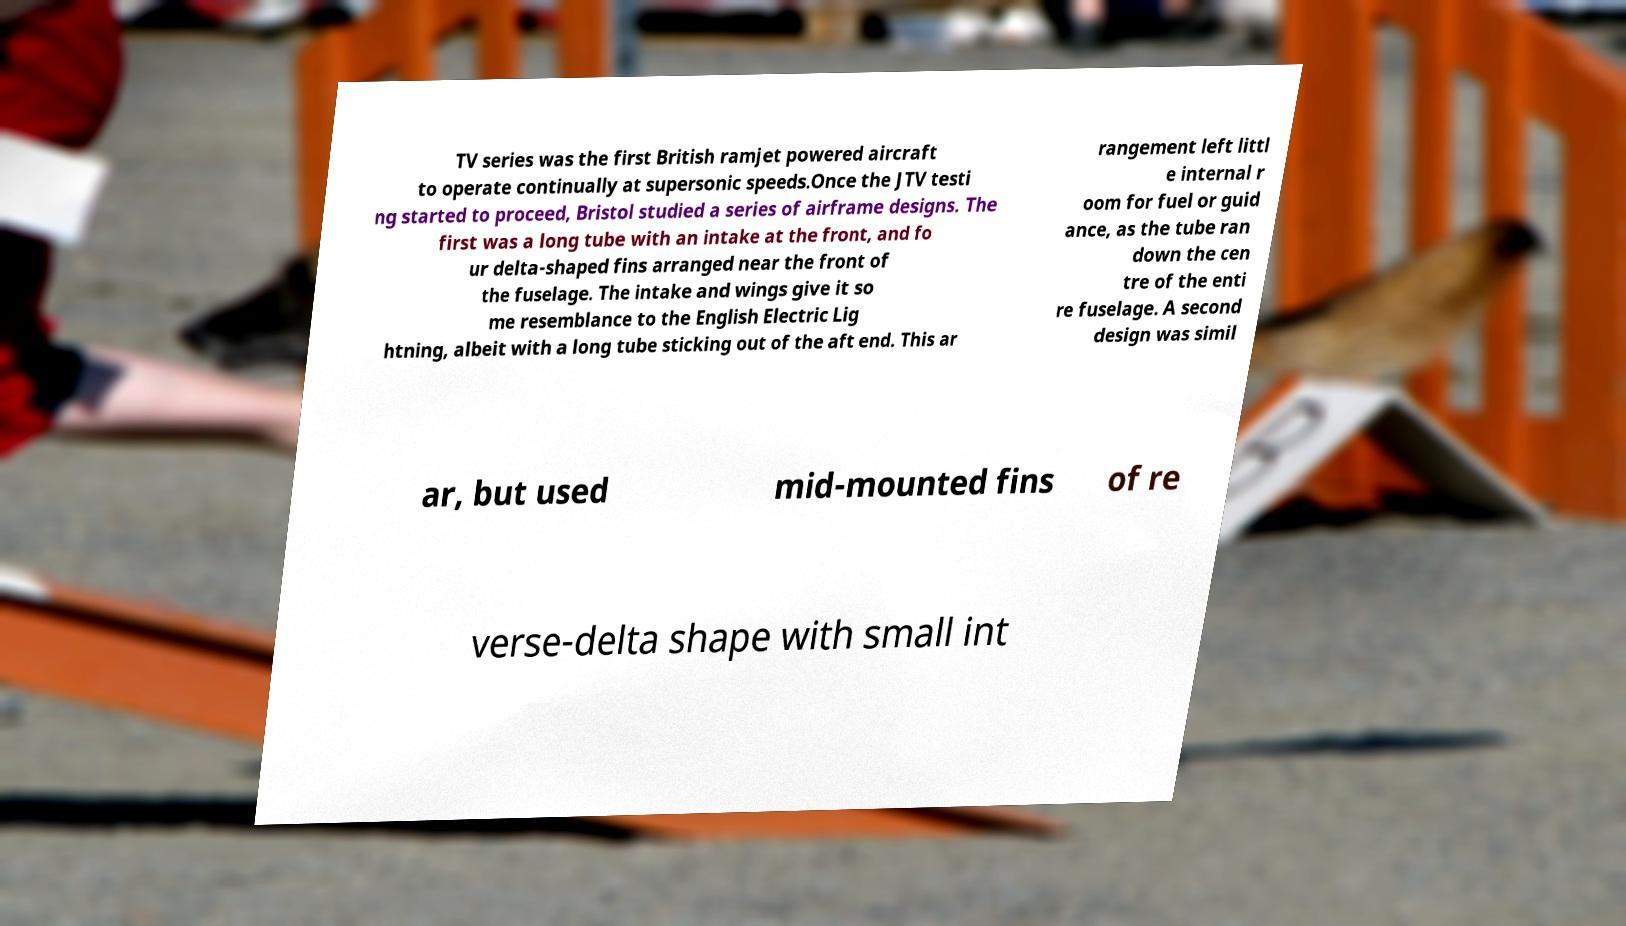I need the written content from this picture converted into text. Can you do that? TV series was the first British ramjet powered aircraft to operate continually at supersonic speeds.Once the JTV testi ng started to proceed, Bristol studied a series of airframe designs. The first was a long tube with an intake at the front, and fo ur delta-shaped fins arranged near the front of the fuselage. The intake and wings give it so me resemblance to the English Electric Lig htning, albeit with a long tube sticking out of the aft end. This ar rangement left littl e internal r oom for fuel or guid ance, as the tube ran down the cen tre of the enti re fuselage. A second design was simil ar, but used mid-mounted fins of re verse-delta shape with small int 